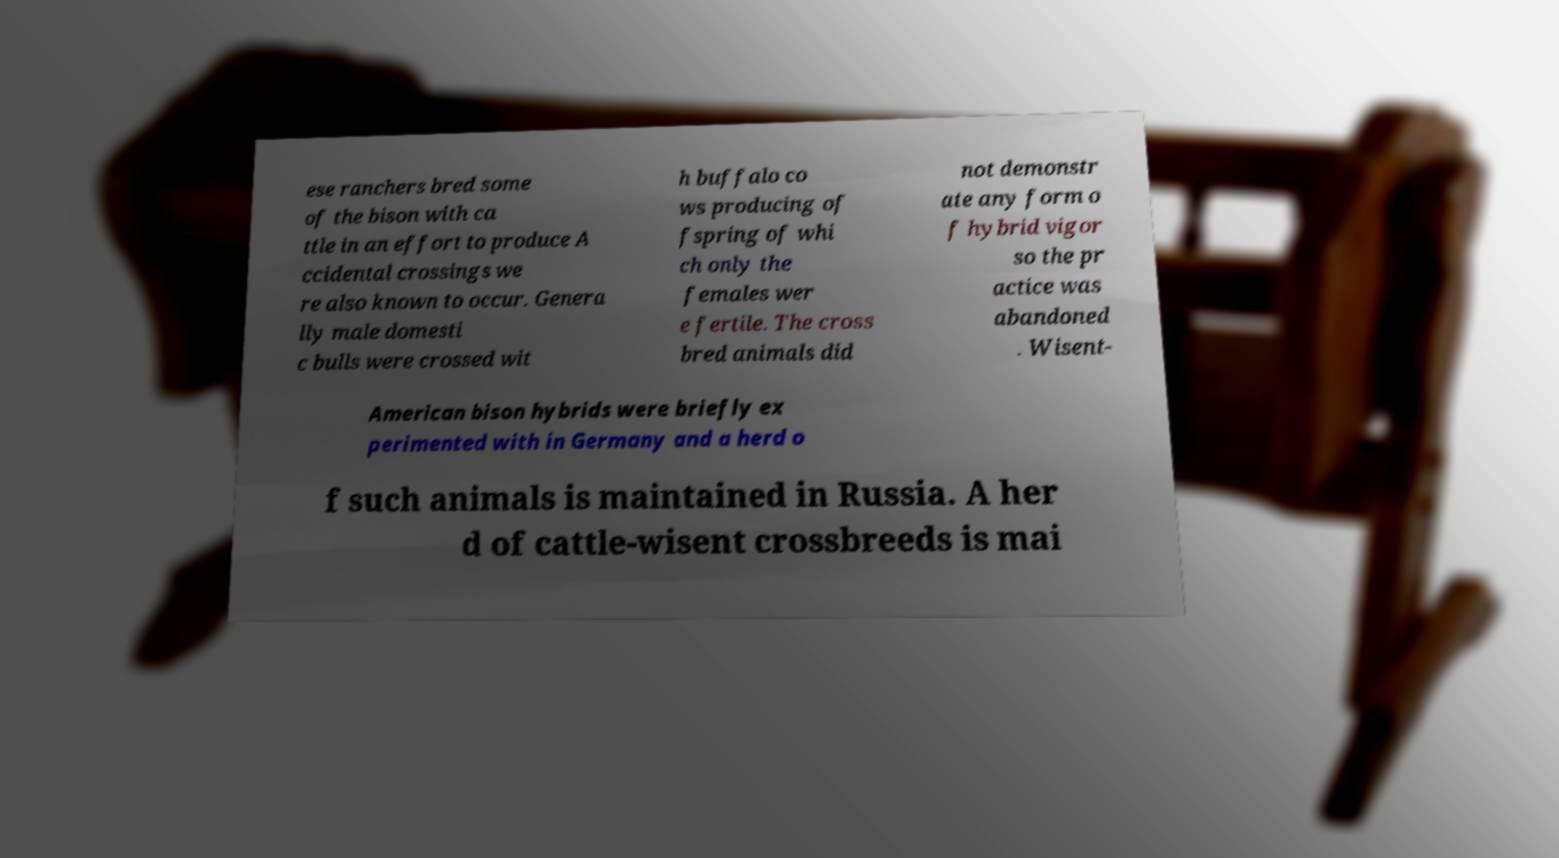Can you read and provide the text displayed in the image?This photo seems to have some interesting text. Can you extract and type it out for me? ese ranchers bred some of the bison with ca ttle in an effort to produce A ccidental crossings we re also known to occur. Genera lly male domesti c bulls were crossed wit h buffalo co ws producing of fspring of whi ch only the females wer e fertile. The cross bred animals did not demonstr ate any form o f hybrid vigor so the pr actice was abandoned . Wisent- American bison hybrids were briefly ex perimented with in Germany and a herd o f such animals is maintained in Russia. A her d of cattle-wisent crossbreeds is mai 